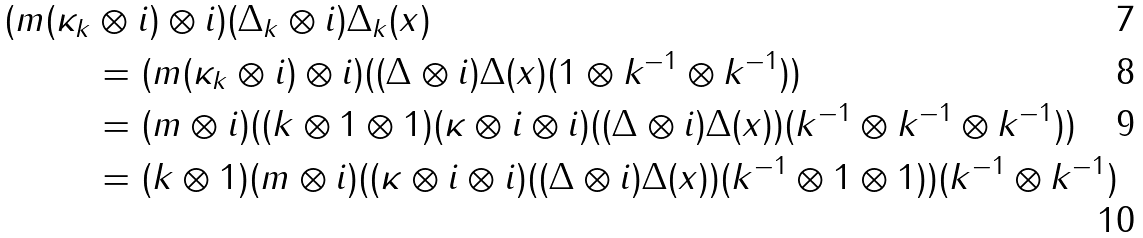<formula> <loc_0><loc_0><loc_500><loc_500>( m ( \kappa _ { k } & \otimes i ) \otimes i ) ( \Delta _ { k } \otimes i ) \Delta _ { k } ( x ) \\ & = ( m ( \kappa _ { k } \otimes i ) \otimes i ) ( ( \Delta \otimes i ) \Delta ( x ) ( 1 \otimes k ^ { - 1 } \otimes k ^ { - 1 } ) ) \\ & = ( m \otimes i ) ( ( k \otimes 1 \otimes 1 ) ( \kappa \otimes i \otimes i ) ( ( \Delta \otimes i ) \Delta ( x ) ) ( k ^ { - 1 } \otimes k ^ { - 1 } \otimes k ^ { - 1 } ) ) \\ & = ( k \otimes 1 ) ( m \otimes i ) ( ( \kappa \otimes i \otimes i ) ( ( \Delta \otimes i ) \Delta ( x ) ) ( k ^ { - 1 } \otimes 1 \otimes 1 ) ) ( k ^ { - 1 } \otimes k ^ { - 1 } )</formula> 